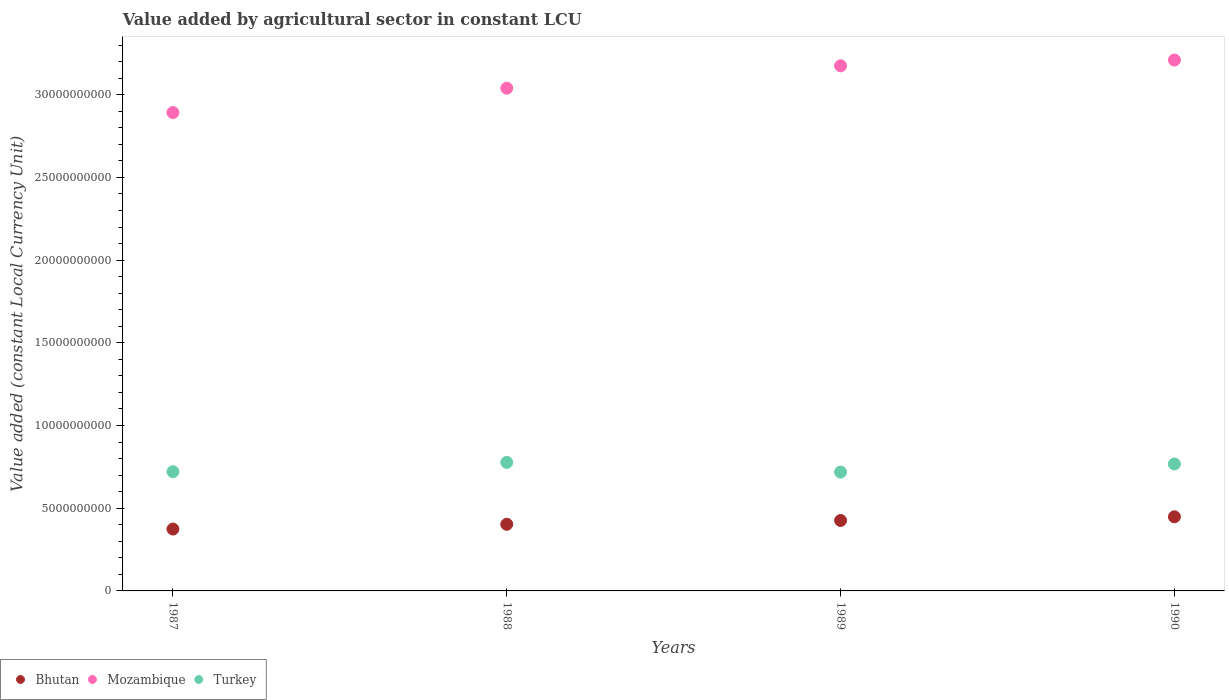How many different coloured dotlines are there?
Give a very brief answer. 3. What is the value added by agricultural sector in Mozambique in 1989?
Your answer should be very brief. 3.17e+1. Across all years, what is the maximum value added by agricultural sector in Mozambique?
Your answer should be very brief. 3.21e+1. Across all years, what is the minimum value added by agricultural sector in Bhutan?
Provide a succinct answer. 3.74e+09. What is the total value added by agricultural sector in Bhutan in the graph?
Offer a terse response. 1.65e+1. What is the difference between the value added by agricultural sector in Bhutan in 1989 and that in 1990?
Keep it short and to the point. -2.24e+08. What is the difference between the value added by agricultural sector in Bhutan in 1990 and the value added by agricultural sector in Turkey in 1987?
Provide a succinct answer. -2.73e+09. What is the average value added by agricultural sector in Mozambique per year?
Give a very brief answer. 3.08e+1. In the year 1990, what is the difference between the value added by agricultural sector in Bhutan and value added by agricultural sector in Turkey?
Offer a terse response. -3.19e+09. What is the ratio of the value added by agricultural sector in Turkey in 1987 to that in 1989?
Provide a succinct answer. 1. Is the value added by agricultural sector in Bhutan in 1988 less than that in 1989?
Keep it short and to the point. Yes. Is the difference between the value added by agricultural sector in Bhutan in 1987 and 1988 greater than the difference between the value added by agricultural sector in Turkey in 1987 and 1988?
Make the answer very short. Yes. What is the difference between the highest and the second highest value added by agricultural sector in Mozambique?
Offer a very short reply. 3.49e+08. What is the difference between the highest and the lowest value added by agricultural sector in Bhutan?
Your answer should be compact. 7.41e+08. Is it the case that in every year, the sum of the value added by agricultural sector in Turkey and value added by agricultural sector in Mozambique  is greater than the value added by agricultural sector in Bhutan?
Your answer should be compact. Yes. Does the value added by agricultural sector in Mozambique monotonically increase over the years?
Offer a terse response. Yes. Is the value added by agricultural sector in Mozambique strictly greater than the value added by agricultural sector in Bhutan over the years?
Your answer should be very brief. Yes. Is the value added by agricultural sector in Mozambique strictly less than the value added by agricultural sector in Bhutan over the years?
Your answer should be very brief. No. How many dotlines are there?
Make the answer very short. 3. How many years are there in the graph?
Keep it short and to the point. 4. Are the values on the major ticks of Y-axis written in scientific E-notation?
Offer a very short reply. No. How many legend labels are there?
Make the answer very short. 3. How are the legend labels stacked?
Give a very brief answer. Horizontal. What is the title of the graph?
Ensure brevity in your answer.  Value added by agricultural sector in constant LCU. Does "Burundi" appear as one of the legend labels in the graph?
Offer a terse response. No. What is the label or title of the Y-axis?
Provide a short and direct response. Value added (constant Local Currency Unit). What is the Value added (constant Local Currency Unit) in Bhutan in 1987?
Offer a very short reply. 3.74e+09. What is the Value added (constant Local Currency Unit) in Mozambique in 1987?
Provide a succinct answer. 2.89e+1. What is the Value added (constant Local Currency Unit) of Turkey in 1987?
Offer a very short reply. 7.21e+09. What is the Value added (constant Local Currency Unit) of Bhutan in 1988?
Your answer should be very brief. 4.03e+09. What is the Value added (constant Local Currency Unit) in Mozambique in 1988?
Make the answer very short. 3.04e+1. What is the Value added (constant Local Currency Unit) of Turkey in 1988?
Ensure brevity in your answer.  7.77e+09. What is the Value added (constant Local Currency Unit) in Bhutan in 1989?
Your answer should be very brief. 4.26e+09. What is the Value added (constant Local Currency Unit) in Mozambique in 1989?
Give a very brief answer. 3.17e+1. What is the Value added (constant Local Currency Unit) of Turkey in 1989?
Offer a very short reply. 7.18e+09. What is the Value added (constant Local Currency Unit) in Bhutan in 1990?
Make the answer very short. 4.48e+09. What is the Value added (constant Local Currency Unit) in Mozambique in 1990?
Your response must be concise. 3.21e+1. What is the Value added (constant Local Currency Unit) of Turkey in 1990?
Offer a terse response. 7.67e+09. Across all years, what is the maximum Value added (constant Local Currency Unit) of Bhutan?
Offer a very short reply. 4.48e+09. Across all years, what is the maximum Value added (constant Local Currency Unit) of Mozambique?
Your answer should be very brief. 3.21e+1. Across all years, what is the maximum Value added (constant Local Currency Unit) in Turkey?
Your answer should be compact. 7.77e+09. Across all years, what is the minimum Value added (constant Local Currency Unit) in Bhutan?
Offer a very short reply. 3.74e+09. Across all years, what is the minimum Value added (constant Local Currency Unit) of Mozambique?
Your answer should be compact. 2.89e+1. Across all years, what is the minimum Value added (constant Local Currency Unit) of Turkey?
Keep it short and to the point. 7.18e+09. What is the total Value added (constant Local Currency Unit) in Bhutan in the graph?
Provide a short and direct response. 1.65e+1. What is the total Value added (constant Local Currency Unit) of Mozambique in the graph?
Your answer should be very brief. 1.23e+11. What is the total Value added (constant Local Currency Unit) of Turkey in the graph?
Make the answer very short. 2.98e+1. What is the difference between the Value added (constant Local Currency Unit) in Bhutan in 1987 and that in 1988?
Make the answer very short. -2.89e+08. What is the difference between the Value added (constant Local Currency Unit) of Mozambique in 1987 and that in 1988?
Your answer should be very brief. -1.47e+09. What is the difference between the Value added (constant Local Currency Unit) in Turkey in 1987 and that in 1988?
Provide a succinct answer. -5.64e+08. What is the difference between the Value added (constant Local Currency Unit) of Bhutan in 1987 and that in 1989?
Offer a terse response. -5.18e+08. What is the difference between the Value added (constant Local Currency Unit) in Mozambique in 1987 and that in 1989?
Ensure brevity in your answer.  -2.83e+09. What is the difference between the Value added (constant Local Currency Unit) of Turkey in 1987 and that in 1989?
Your answer should be very brief. 2.28e+07. What is the difference between the Value added (constant Local Currency Unit) in Bhutan in 1987 and that in 1990?
Provide a short and direct response. -7.41e+08. What is the difference between the Value added (constant Local Currency Unit) in Mozambique in 1987 and that in 1990?
Make the answer very short. -3.18e+09. What is the difference between the Value added (constant Local Currency Unit) in Turkey in 1987 and that in 1990?
Offer a terse response. -4.67e+08. What is the difference between the Value added (constant Local Currency Unit) of Bhutan in 1988 and that in 1989?
Make the answer very short. -2.28e+08. What is the difference between the Value added (constant Local Currency Unit) of Mozambique in 1988 and that in 1989?
Your response must be concise. -1.35e+09. What is the difference between the Value added (constant Local Currency Unit) of Turkey in 1988 and that in 1989?
Offer a terse response. 5.87e+08. What is the difference between the Value added (constant Local Currency Unit) in Bhutan in 1988 and that in 1990?
Offer a terse response. -4.52e+08. What is the difference between the Value added (constant Local Currency Unit) in Mozambique in 1988 and that in 1990?
Your answer should be compact. -1.70e+09. What is the difference between the Value added (constant Local Currency Unit) of Turkey in 1988 and that in 1990?
Your response must be concise. 9.72e+07. What is the difference between the Value added (constant Local Currency Unit) of Bhutan in 1989 and that in 1990?
Ensure brevity in your answer.  -2.24e+08. What is the difference between the Value added (constant Local Currency Unit) in Mozambique in 1989 and that in 1990?
Your answer should be compact. -3.49e+08. What is the difference between the Value added (constant Local Currency Unit) in Turkey in 1989 and that in 1990?
Provide a succinct answer. -4.90e+08. What is the difference between the Value added (constant Local Currency Unit) in Bhutan in 1987 and the Value added (constant Local Currency Unit) in Mozambique in 1988?
Your answer should be very brief. -2.67e+1. What is the difference between the Value added (constant Local Currency Unit) in Bhutan in 1987 and the Value added (constant Local Currency Unit) in Turkey in 1988?
Offer a terse response. -4.03e+09. What is the difference between the Value added (constant Local Currency Unit) in Mozambique in 1987 and the Value added (constant Local Currency Unit) in Turkey in 1988?
Offer a very short reply. 2.11e+1. What is the difference between the Value added (constant Local Currency Unit) of Bhutan in 1987 and the Value added (constant Local Currency Unit) of Mozambique in 1989?
Your answer should be compact. -2.80e+1. What is the difference between the Value added (constant Local Currency Unit) of Bhutan in 1987 and the Value added (constant Local Currency Unit) of Turkey in 1989?
Offer a very short reply. -3.44e+09. What is the difference between the Value added (constant Local Currency Unit) of Mozambique in 1987 and the Value added (constant Local Currency Unit) of Turkey in 1989?
Ensure brevity in your answer.  2.17e+1. What is the difference between the Value added (constant Local Currency Unit) of Bhutan in 1987 and the Value added (constant Local Currency Unit) of Mozambique in 1990?
Your answer should be very brief. -2.84e+1. What is the difference between the Value added (constant Local Currency Unit) in Bhutan in 1987 and the Value added (constant Local Currency Unit) in Turkey in 1990?
Ensure brevity in your answer.  -3.93e+09. What is the difference between the Value added (constant Local Currency Unit) of Mozambique in 1987 and the Value added (constant Local Currency Unit) of Turkey in 1990?
Keep it short and to the point. 2.12e+1. What is the difference between the Value added (constant Local Currency Unit) of Bhutan in 1988 and the Value added (constant Local Currency Unit) of Mozambique in 1989?
Offer a very short reply. -2.77e+1. What is the difference between the Value added (constant Local Currency Unit) in Bhutan in 1988 and the Value added (constant Local Currency Unit) in Turkey in 1989?
Your response must be concise. -3.16e+09. What is the difference between the Value added (constant Local Currency Unit) in Mozambique in 1988 and the Value added (constant Local Currency Unit) in Turkey in 1989?
Your response must be concise. 2.32e+1. What is the difference between the Value added (constant Local Currency Unit) of Bhutan in 1988 and the Value added (constant Local Currency Unit) of Mozambique in 1990?
Offer a terse response. -2.81e+1. What is the difference between the Value added (constant Local Currency Unit) of Bhutan in 1988 and the Value added (constant Local Currency Unit) of Turkey in 1990?
Give a very brief answer. -3.64e+09. What is the difference between the Value added (constant Local Currency Unit) in Mozambique in 1988 and the Value added (constant Local Currency Unit) in Turkey in 1990?
Provide a succinct answer. 2.27e+1. What is the difference between the Value added (constant Local Currency Unit) in Bhutan in 1989 and the Value added (constant Local Currency Unit) in Mozambique in 1990?
Offer a terse response. -2.78e+1. What is the difference between the Value added (constant Local Currency Unit) in Bhutan in 1989 and the Value added (constant Local Currency Unit) in Turkey in 1990?
Provide a succinct answer. -3.42e+09. What is the difference between the Value added (constant Local Currency Unit) of Mozambique in 1989 and the Value added (constant Local Currency Unit) of Turkey in 1990?
Offer a terse response. 2.41e+1. What is the average Value added (constant Local Currency Unit) in Bhutan per year?
Provide a short and direct response. 4.13e+09. What is the average Value added (constant Local Currency Unit) in Mozambique per year?
Your answer should be compact. 3.08e+1. What is the average Value added (constant Local Currency Unit) of Turkey per year?
Make the answer very short. 7.46e+09. In the year 1987, what is the difference between the Value added (constant Local Currency Unit) in Bhutan and Value added (constant Local Currency Unit) in Mozambique?
Offer a terse response. -2.52e+1. In the year 1987, what is the difference between the Value added (constant Local Currency Unit) of Bhutan and Value added (constant Local Currency Unit) of Turkey?
Offer a terse response. -3.47e+09. In the year 1987, what is the difference between the Value added (constant Local Currency Unit) of Mozambique and Value added (constant Local Currency Unit) of Turkey?
Keep it short and to the point. 2.17e+1. In the year 1988, what is the difference between the Value added (constant Local Currency Unit) of Bhutan and Value added (constant Local Currency Unit) of Mozambique?
Offer a very short reply. -2.64e+1. In the year 1988, what is the difference between the Value added (constant Local Currency Unit) of Bhutan and Value added (constant Local Currency Unit) of Turkey?
Offer a terse response. -3.74e+09. In the year 1988, what is the difference between the Value added (constant Local Currency Unit) in Mozambique and Value added (constant Local Currency Unit) in Turkey?
Offer a terse response. 2.26e+1. In the year 1989, what is the difference between the Value added (constant Local Currency Unit) of Bhutan and Value added (constant Local Currency Unit) of Mozambique?
Keep it short and to the point. -2.75e+1. In the year 1989, what is the difference between the Value added (constant Local Currency Unit) in Bhutan and Value added (constant Local Currency Unit) in Turkey?
Make the answer very short. -2.93e+09. In the year 1989, what is the difference between the Value added (constant Local Currency Unit) of Mozambique and Value added (constant Local Currency Unit) of Turkey?
Give a very brief answer. 2.46e+1. In the year 1990, what is the difference between the Value added (constant Local Currency Unit) of Bhutan and Value added (constant Local Currency Unit) of Mozambique?
Your answer should be very brief. -2.76e+1. In the year 1990, what is the difference between the Value added (constant Local Currency Unit) of Bhutan and Value added (constant Local Currency Unit) of Turkey?
Keep it short and to the point. -3.19e+09. In the year 1990, what is the difference between the Value added (constant Local Currency Unit) of Mozambique and Value added (constant Local Currency Unit) of Turkey?
Your answer should be very brief. 2.44e+1. What is the ratio of the Value added (constant Local Currency Unit) of Bhutan in 1987 to that in 1988?
Keep it short and to the point. 0.93. What is the ratio of the Value added (constant Local Currency Unit) in Mozambique in 1987 to that in 1988?
Your answer should be very brief. 0.95. What is the ratio of the Value added (constant Local Currency Unit) in Turkey in 1987 to that in 1988?
Make the answer very short. 0.93. What is the ratio of the Value added (constant Local Currency Unit) of Bhutan in 1987 to that in 1989?
Your answer should be compact. 0.88. What is the ratio of the Value added (constant Local Currency Unit) of Mozambique in 1987 to that in 1989?
Offer a terse response. 0.91. What is the ratio of the Value added (constant Local Currency Unit) in Turkey in 1987 to that in 1989?
Your answer should be very brief. 1. What is the ratio of the Value added (constant Local Currency Unit) in Bhutan in 1987 to that in 1990?
Provide a short and direct response. 0.83. What is the ratio of the Value added (constant Local Currency Unit) in Mozambique in 1987 to that in 1990?
Make the answer very short. 0.9. What is the ratio of the Value added (constant Local Currency Unit) in Turkey in 1987 to that in 1990?
Give a very brief answer. 0.94. What is the ratio of the Value added (constant Local Currency Unit) of Bhutan in 1988 to that in 1989?
Make the answer very short. 0.95. What is the ratio of the Value added (constant Local Currency Unit) of Mozambique in 1988 to that in 1989?
Give a very brief answer. 0.96. What is the ratio of the Value added (constant Local Currency Unit) in Turkey in 1988 to that in 1989?
Provide a short and direct response. 1.08. What is the ratio of the Value added (constant Local Currency Unit) in Bhutan in 1988 to that in 1990?
Make the answer very short. 0.9. What is the ratio of the Value added (constant Local Currency Unit) in Mozambique in 1988 to that in 1990?
Your answer should be very brief. 0.95. What is the ratio of the Value added (constant Local Currency Unit) in Turkey in 1988 to that in 1990?
Offer a very short reply. 1.01. What is the ratio of the Value added (constant Local Currency Unit) in Bhutan in 1989 to that in 1990?
Your response must be concise. 0.95. What is the ratio of the Value added (constant Local Currency Unit) of Turkey in 1989 to that in 1990?
Your answer should be very brief. 0.94. What is the difference between the highest and the second highest Value added (constant Local Currency Unit) in Bhutan?
Ensure brevity in your answer.  2.24e+08. What is the difference between the highest and the second highest Value added (constant Local Currency Unit) in Mozambique?
Your response must be concise. 3.49e+08. What is the difference between the highest and the second highest Value added (constant Local Currency Unit) of Turkey?
Your answer should be compact. 9.72e+07. What is the difference between the highest and the lowest Value added (constant Local Currency Unit) of Bhutan?
Give a very brief answer. 7.41e+08. What is the difference between the highest and the lowest Value added (constant Local Currency Unit) of Mozambique?
Give a very brief answer. 3.18e+09. What is the difference between the highest and the lowest Value added (constant Local Currency Unit) in Turkey?
Offer a terse response. 5.87e+08. 